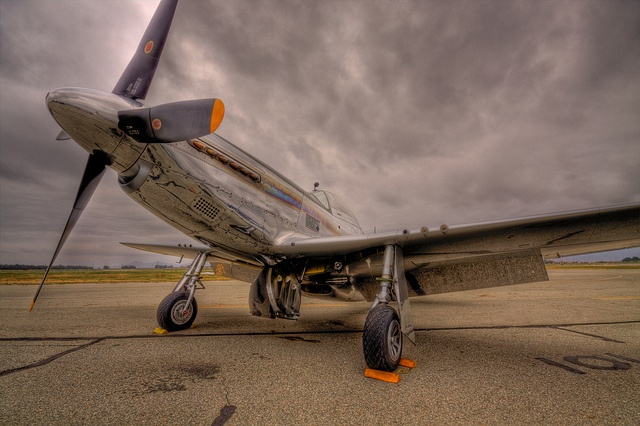Describe the objects in this image and their specific colors. I can see a airplane in gray, black, and maroon tones in this image. 